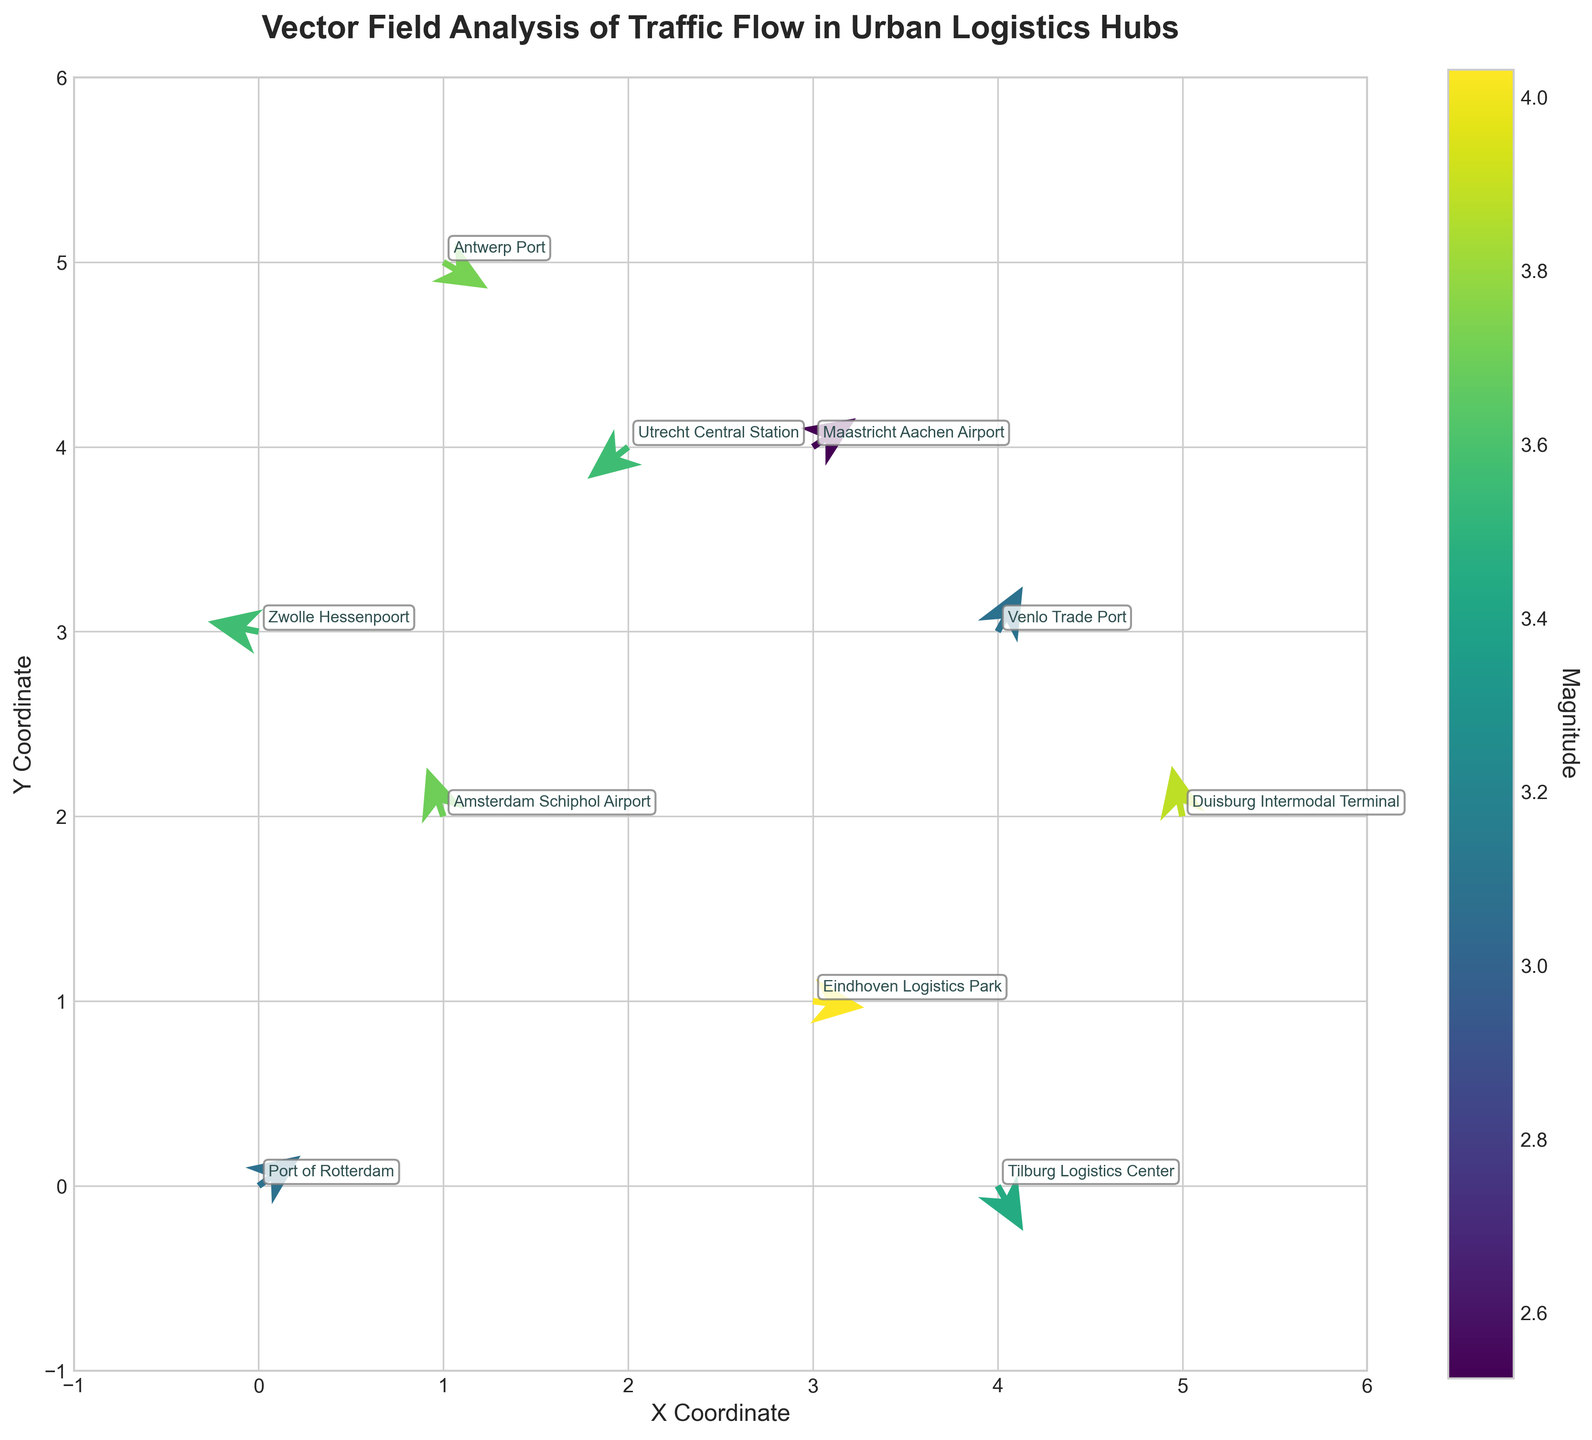What is the title of the figure? The title of the figure is displayed prominently at the top of the plot. It summarizes the overall purpose and theme of the plot.
Answer: Vector Field Analysis of Traffic Flow in Urban Logistics Hubs How many locations are analyzed in the figure? Count the number of annotated locations on the plot. Each location has a unique name.
Answer: 10 Which location has the highest magnitude of traffic flow? Compare the magnitudes of traffic flow (indicated by the color bar and annotation) for each location. Find the maximum value.
Answer: Eindhoven Logistics Park Are there any locations where the traffic flow vectors point directly horizontally or vertically? Examine the direction of the vectors. A horizontal vector would have either a u-component of 0 or a v-component of 0.
Answer: No Which locations show traffic flow in the upward direction? Identify vectors with a positive v-component, indicating upward direction. Annotate these locations.
Answer: Amsterdam Schiphol Airport, Venlo Trade Port, Duisburg Intermodal Terminal, Maastricht Aachen Airport What is the main difference in traffic flow direction between Arnhem and Tilburg? Compare the vectors of Arnhem (3, 3) and Tilburg (4, 0). Assess the orientation (u, v) of each vector.
Answer: Arnhem: Upward-Left, Tilburg: Downward-Right Which location has the smallest (shortest) traffic flow vector? Check the magnitude values of each location to find the smallest one.
Answer: Maastricht Aachen Airport Is there any location where the traffic flow vector has a significant horizontal component but a small vertical component? Look for a large u-component and a small v-component in any vector. Examine the annotation for precise values.
Answer: Eindhoven Logistics Park Are there any locations with negative u and v components? Identify vectors with both u and v components being negative, indicating a south-west direction.
Answer: Utrecht Central Station Which locations have traffic flow vectors predominantly pointing towards the south-east? Analyze the vectors where both u and v components are positive, indicating a south-east direction.
Answer: Venlo Trade Port, Antwerp Port, Maastricht Aachen Airport 